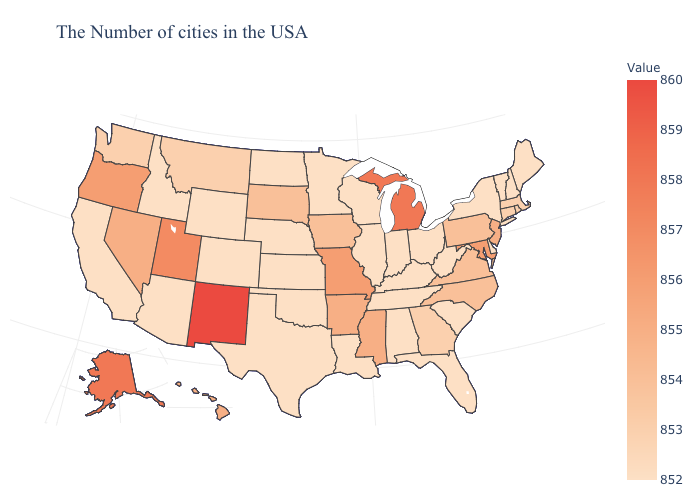Among the states that border Illinois , does Iowa have the lowest value?
Concise answer only. No. Which states have the lowest value in the USA?
Short answer required. Maine, New Hampshire, Vermont, New York, Delaware, South Carolina, West Virginia, Ohio, Florida, Kentucky, Indiana, Alabama, Tennessee, Wisconsin, Illinois, Louisiana, Minnesota, Kansas, Nebraska, Oklahoma, Texas, North Dakota, Wyoming, Colorado, Arizona, Idaho, California. 